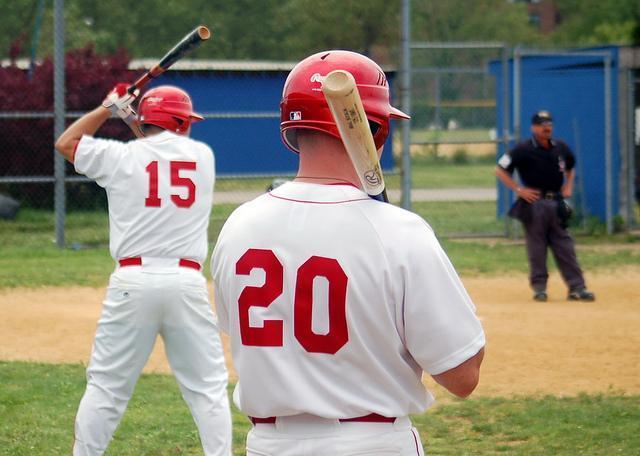How many players are there?
Give a very brief answer. 2. How many people are there?
Give a very brief answer. 3. How many green keyboards are on the table?
Give a very brief answer. 0. 